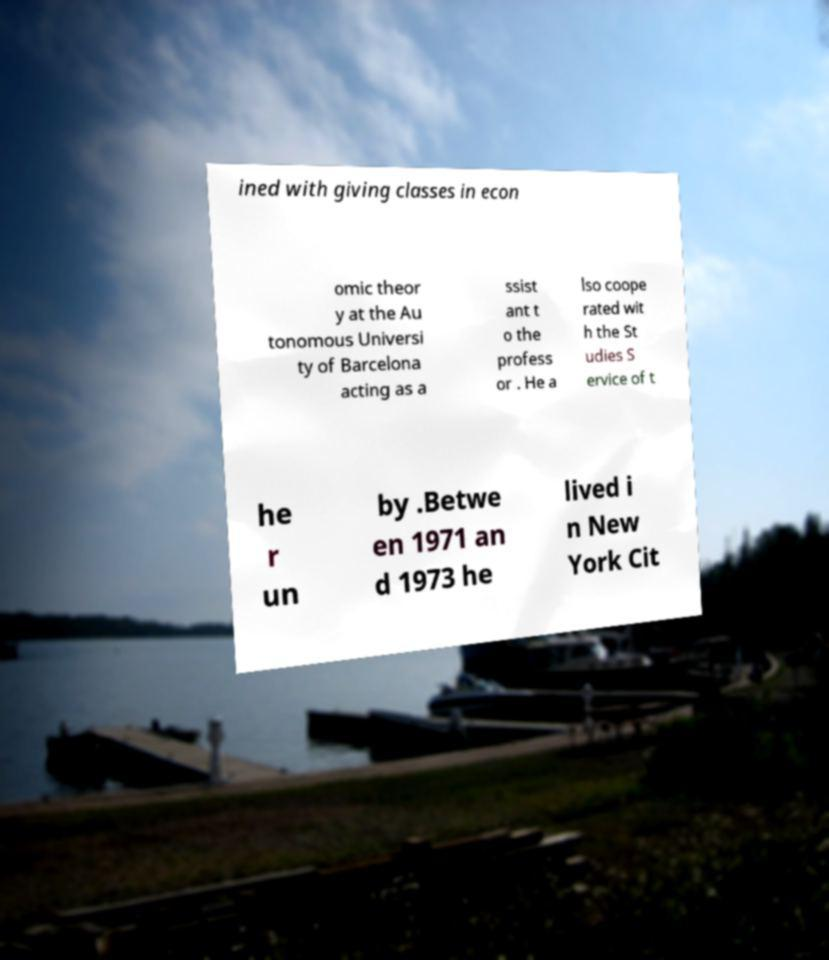There's text embedded in this image that I need extracted. Can you transcribe it verbatim? ined with giving classes in econ omic theor y at the Au tonomous Universi ty of Barcelona acting as a ssist ant t o the profess or . He a lso coope rated wit h the St udies S ervice of t he r un by .Betwe en 1971 an d 1973 he lived i n New York Cit 